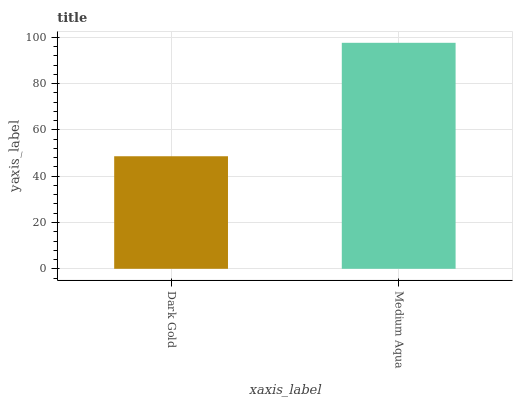Is Medium Aqua the minimum?
Answer yes or no. No. Is Medium Aqua greater than Dark Gold?
Answer yes or no. Yes. Is Dark Gold less than Medium Aqua?
Answer yes or no. Yes. Is Dark Gold greater than Medium Aqua?
Answer yes or no. No. Is Medium Aqua less than Dark Gold?
Answer yes or no. No. Is Medium Aqua the high median?
Answer yes or no. Yes. Is Dark Gold the low median?
Answer yes or no. Yes. Is Dark Gold the high median?
Answer yes or no. No. Is Medium Aqua the low median?
Answer yes or no. No. 